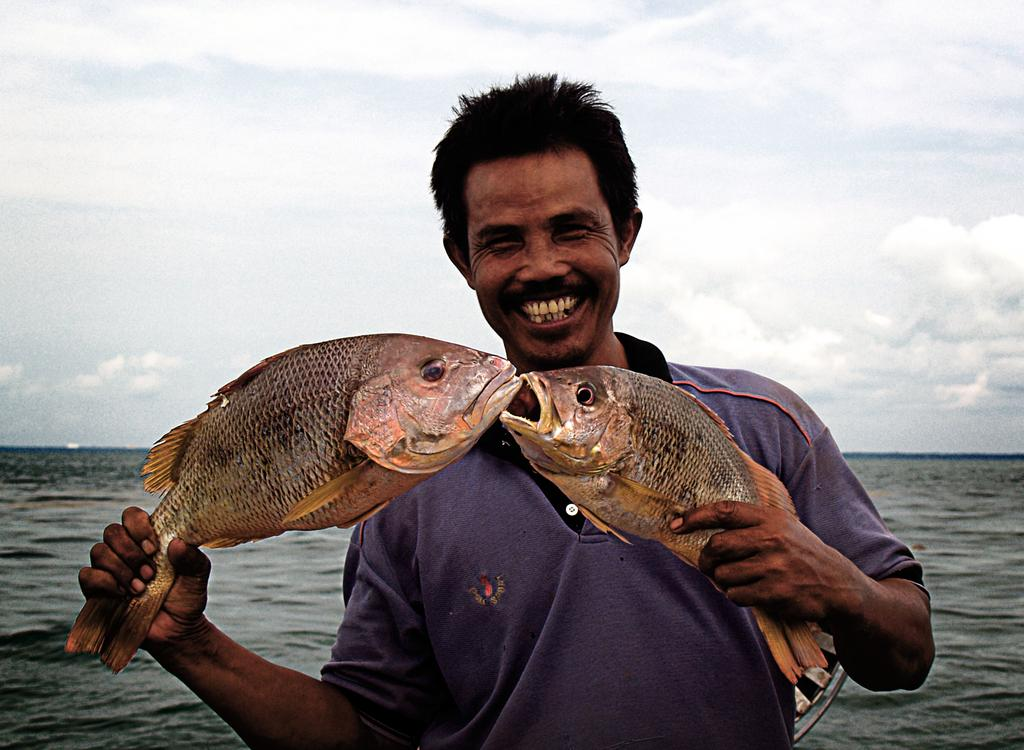What is the main subject of the image? There is a person in the image. What is the person holding in their hand? The person is holding a fish in their hand. What type of environment is visible in the image? There is a sea visible in the image. What can be seen in the sky in the image? There are clouds in the sky in the image. How many wishes can be granted by the fish in the image? There is no indication in the image that the fish has the ability to grant wishes, so it cannot be determined from the picture. 